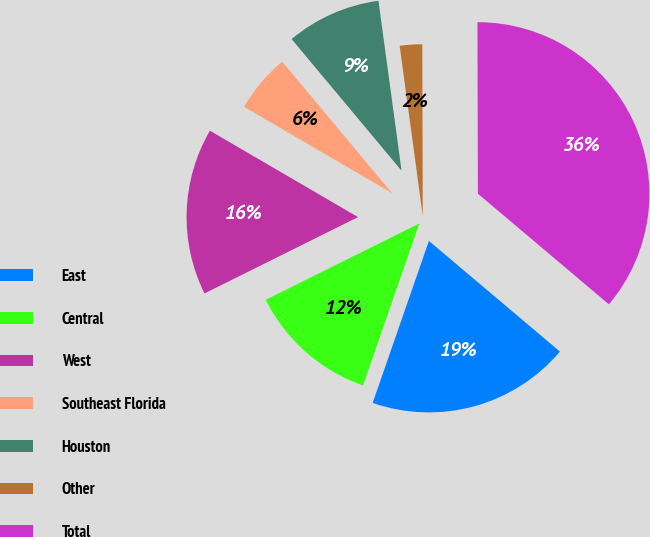<chart> <loc_0><loc_0><loc_500><loc_500><pie_chart><fcel>East<fcel>Central<fcel>West<fcel>Southeast Florida<fcel>Houston<fcel>Other<fcel>Total<nl><fcel>19.16%<fcel>12.34%<fcel>15.75%<fcel>5.52%<fcel>8.93%<fcel>2.11%<fcel>36.21%<nl></chart> 